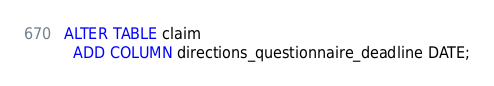Convert code to text. <code><loc_0><loc_0><loc_500><loc_500><_SQL_>ALTER TABLE claim
  ADD COLUMN directions_questionnaire_deadline DATE;
</code> 